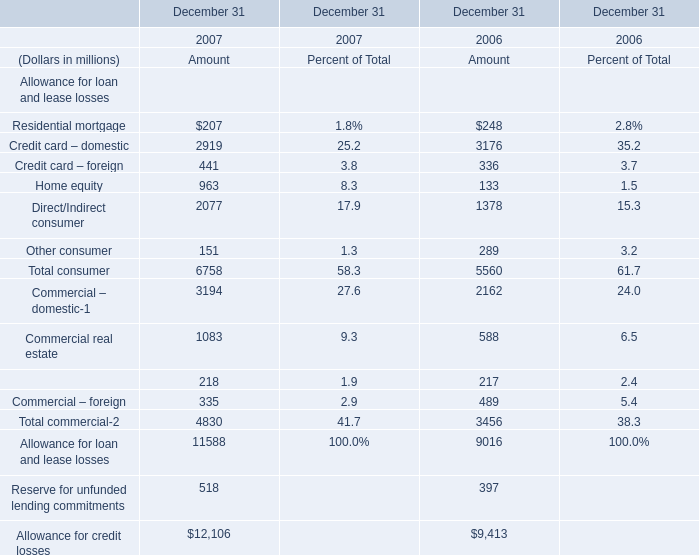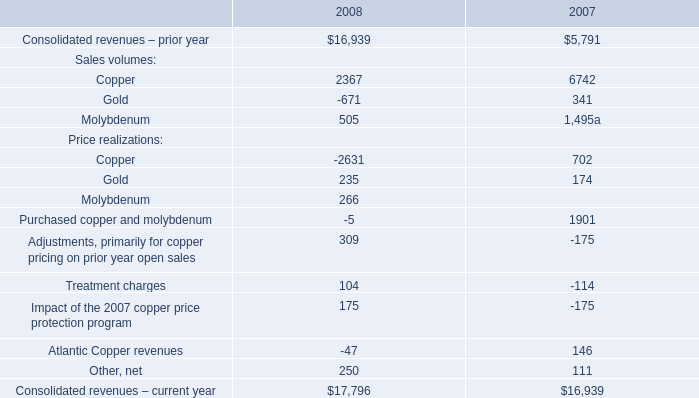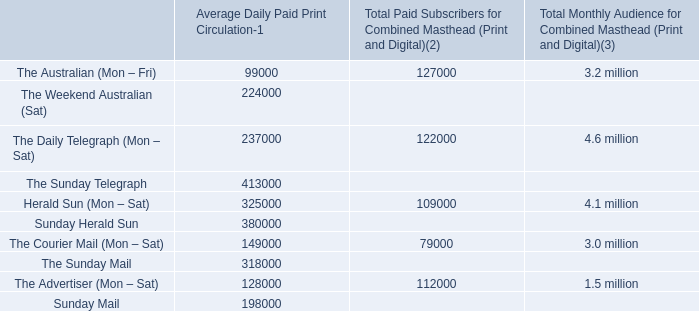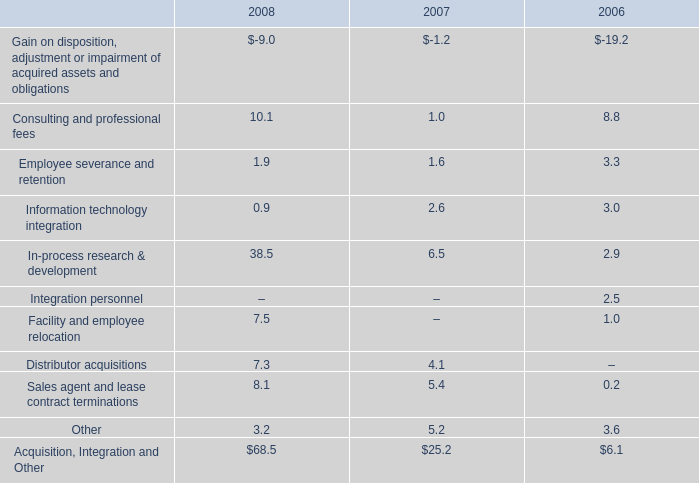What's the average of Residential mortgage and Credit card – domestic in 2007? (in million) 
Computations: ((207 + 2919) / 2)
Answer: 1563.0. 